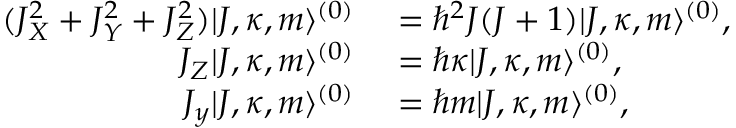<formula> <loc_0><loc_0><loc_500><loc_500>\begin{array} { r l } { ( J _ { X } ^ { 2 } + J _ { Y } ^ { 2 } + J _ { Z } ^ { 2 } ) | J , \kappa , m \rangle ^ { ( 0 ) } } & = \hbar { ^ } { 2 } J ( J + 1 ) | J , \kappa , m \rangle ^ { ( 0 ) } , } \\ { J _ { Z } | J , \kappa , m \rangle ^ { ( 0 ) } } & = \hbar { \kappa } | J , \kappa , m \rangle ^ { ( 0 ) } , } \\ { J _ { y } | J , \kappa , m \rangle ^ { ( 0 ) } } & = \hbar { m } | J , \kappa , m \rangle ^ { ( 0 ) } , } \end{array}</formula> 